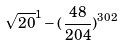<formula> <loc_0><loc_0><loc_500><loc_500>\sqrt { 2 0 } ^ { 1 } - ( \frac { 4 8 } { 2 0 4 } ) ^ { 3 0 2 }</formula> 